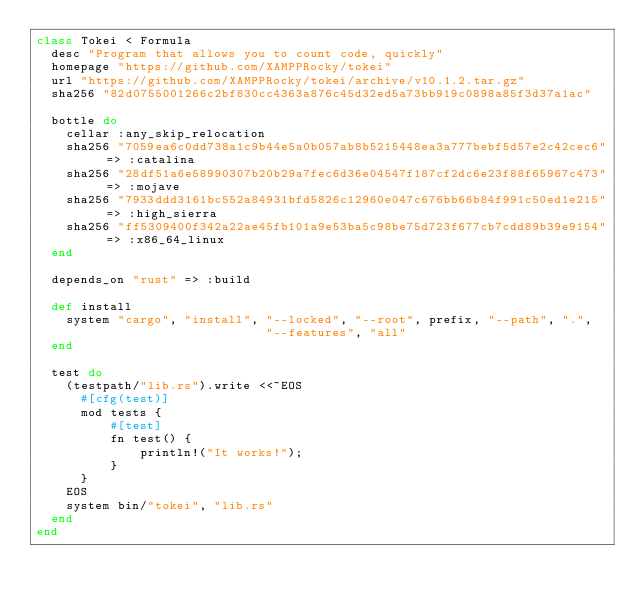<code> <loc_0><loc_0><loc_500><loc_500><_Ruby_>class Tokei < Formula
  desc "Program that allows you to count code, quickly"
  homepage "https://github.com/XAMPPRocky/tokei"
  url "https://github.com/XAMPPRocky/tokei/archive/v10.1.2.tar.gz"
  sha256 "82d0755001266c2bf830cc4363a876c45d32ed5a73bb919c0898a85f3d37a1ac"

  bottle do
    cellar :any_skip_relocation
    sha256 "7059ea6c0dd738a1c9b44e5a0b057ab8b5215448ea3a777bebf5d57e2c42cec6" => :catalina
    sha256 "28df51a6e58990307b20b29a7fec6d36e04547f187cf2dc6e23f88f65967c473" => :mojave
    sha256 "7933ddd3161bc552a84931bfd5826c12960e047c676bb66b84f991c50ed1e215" => :high_sierra
    sha256 "ff5309400f342a22ae45fb101a9e53ba5c98be75d723f677cb7cdd89b39e9154" => :x86_64_linux
  end

  depends_on "rust" => :build

  def install
    system "cargo", "install", "--locked", "--root", prefix, "--path", ".",
                               "--features", "all"
  end

  test do
    (testpath/"lib.rs").write <<~EOS
      #[cfg(test)]
      mod tests {
          #[test]
          fn test() {
              println!("It works!");
          }
      }
    EOS
    system bin/"tokei", "lib.rs"
  end
end
</code> 